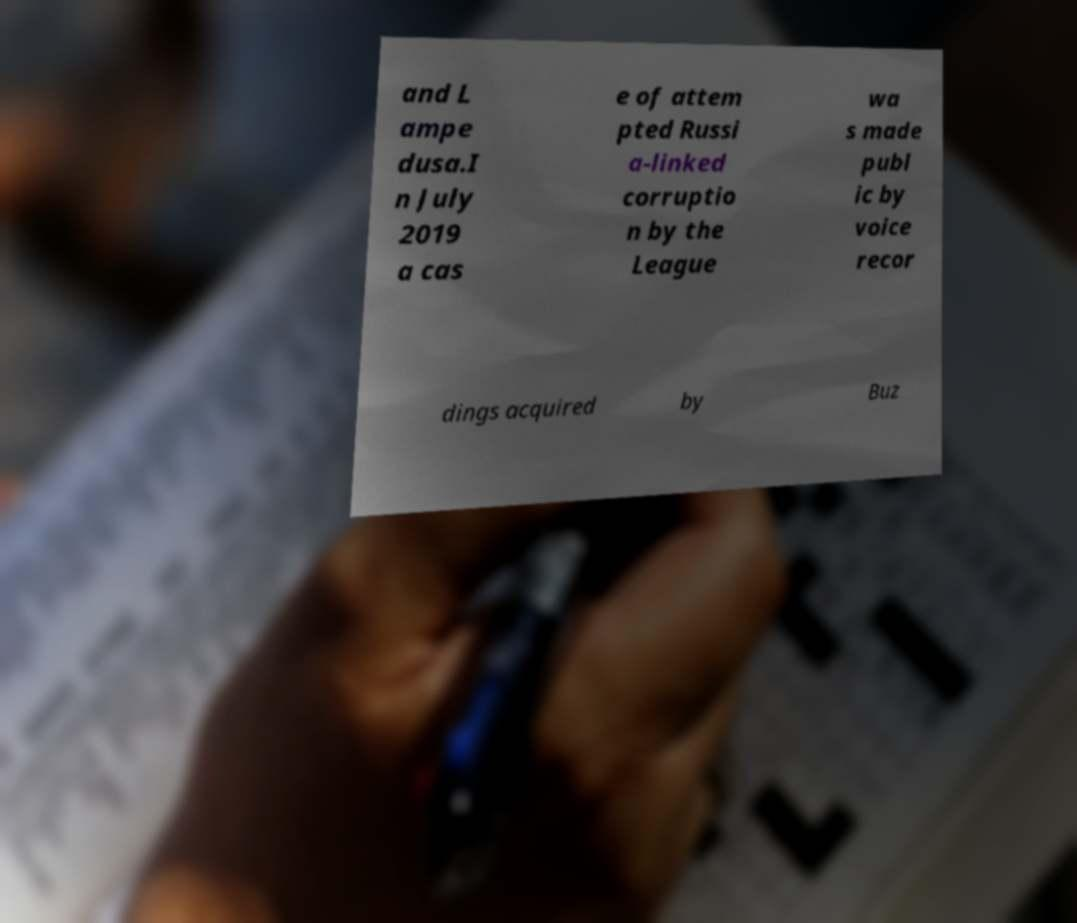Can you read and provide the text displayed in the image?This photo seems to have some interesting text. Can you extract and type it out for me? and L ampe dusa.I n July 2019 a cas e of attem pted Russi a-linked corruptio n by the League wa s made publ ic by voice recor dings acquired by Buz 